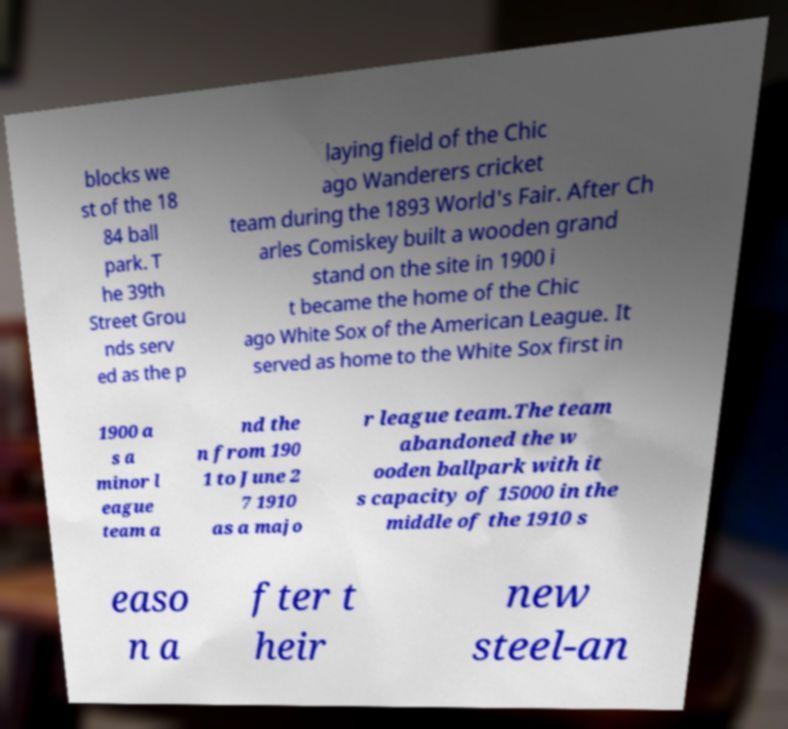Can you read and provide the text displayed in the image?This photo seems to have some interesting text. Can you extract and type it out for me? blocks we st of the 18 84 ball park. T he 39th Street Grou nds serv ed as the p laying field of the Chic ago Wanderers cricket team during the 1893 World's Fair. After Ch arles Comiskey built a wooden grand stand on the site in 1900 i t became the home of the Chic ago White Sox of the American League. It served as home to the White Sox first in 1900 a s a minor l eague team a nd the n from 190 1 to June 2 7 1910 as a majo r league team.The team abandoned the w ooden ballpark with it s capacity of 15000 in the middle of the 1910 s easo n a fter t heir new steel-an 